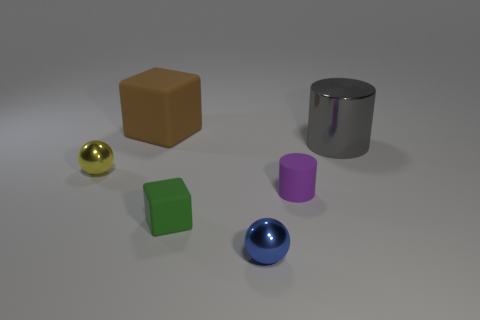There is a rubber block in front of the yellow metal object; is there a large gray shiny object left of it? Upon looking at the image, the large gray shiny object appears to be a cylindrical metal container, and indeed, it is positioned to the left of the yellow metal object, assuming we are considering left from the perspective of the viewer. 